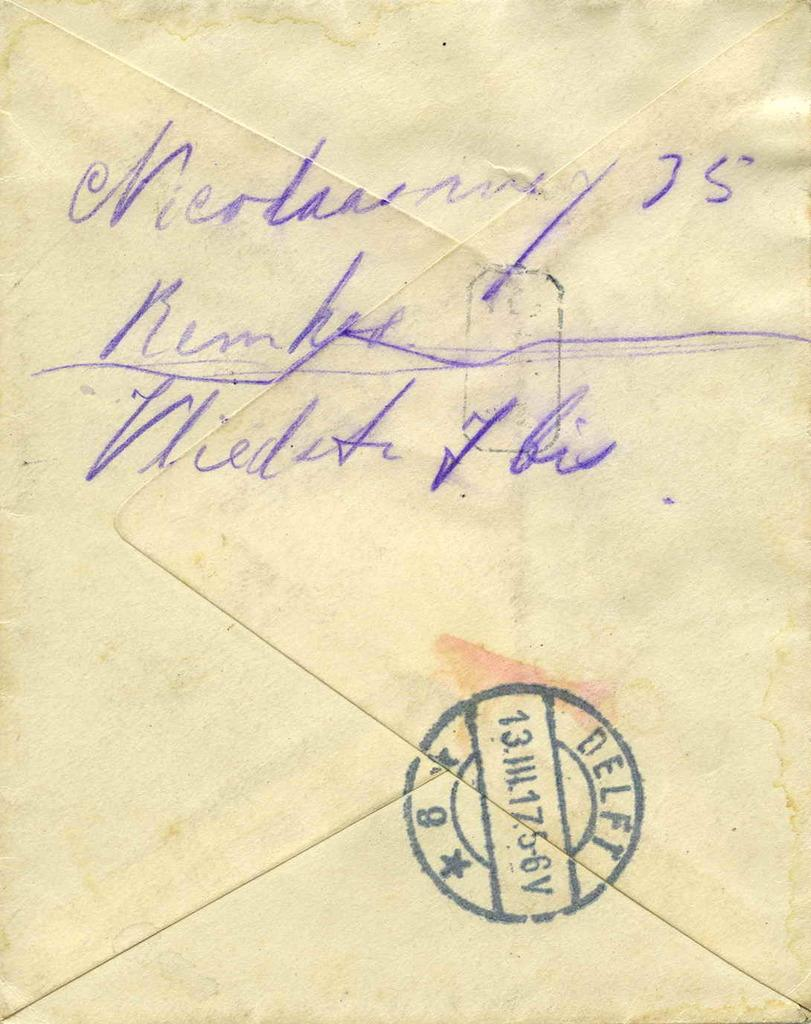<image>
Share a concise interpretation of the image provided. the back flap of a  postmarked envelope from delft 